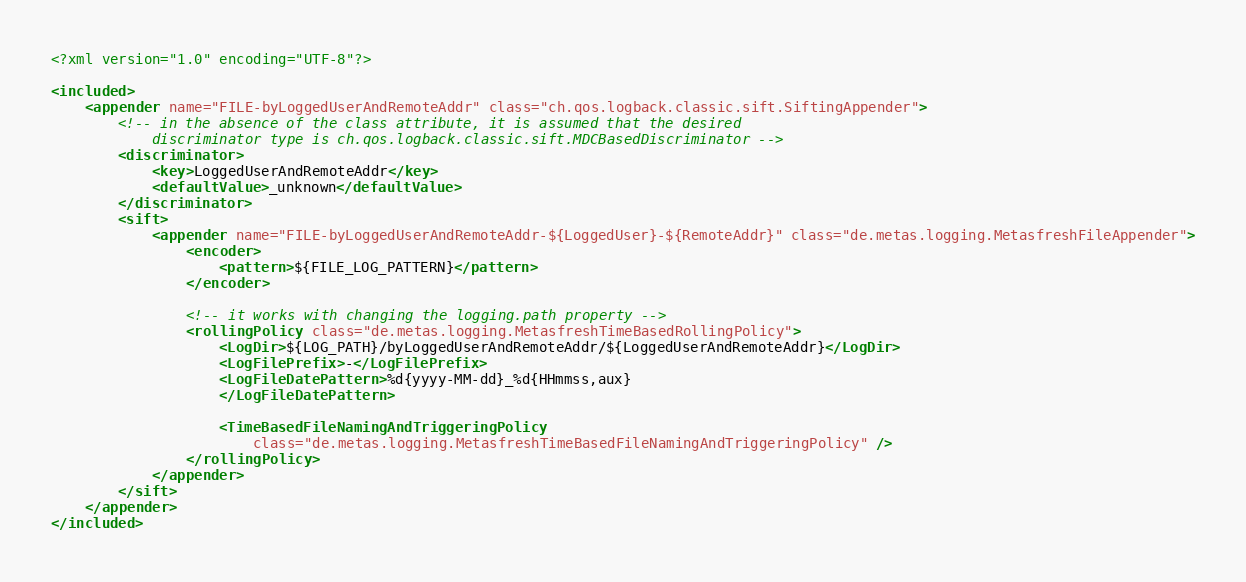<code> <loc_0><loc_0><loc_500><loc_500><_XML_><?xml version="1.0" encoding="UTF-8"?>

<included>
	<appender name="FILE-byLoggedUserAndRemoteAddr" class="ch.qos.logback.classic.sift.SiftingAppender">
		<!-- in the absence of the class attribute, it is assumed that the desired 
			discriminator type is ch.qos.logback.classic.sift.MDCBasedDiscriminator -->
		<discriminator>
			<key>LoggedUserAndRemoteAddr</key>
			<defaultValue>_unknown</defaultValue>
		</discriminator>
		<sift>
			<appender name="FILE-byLoggedUserAndRemoteAddr-${LoggedUser}-${RemoteAddr}" class="de.metas.logging.MetasfreshFileAppender">
				<encoder>
					<pattern>${FILE_LOG_PATTERN}</pattern>
				</encoder>

				<!-- it works with changing the logging.path property -->
				<rollingPolicy class="de.metas.logging.MetasfreshTimeBasedRollingPolicy">
					<LogDir>${LOG_PATH}/byLoggedUserAndRemoteAddr/${LoggedUserAndRemoteAddr}</LogDir>
					<LogFilePrefix>-</LogFilePrefix>
					<LogFileDatePattern>%d{yyyy-MM-dd}_%d{HHmmss,aux}
					</LogFileDatePattern>

					<TimeBasedFileNamingAndTriggeringPolicy
						class="de.metas.logging.MetasfreshTimeBasedFileNamingAndTriggeringPolicy" />
				</rollingPolicy>
			</appender>
		</sift>
	</appender>
</included>
</code> 